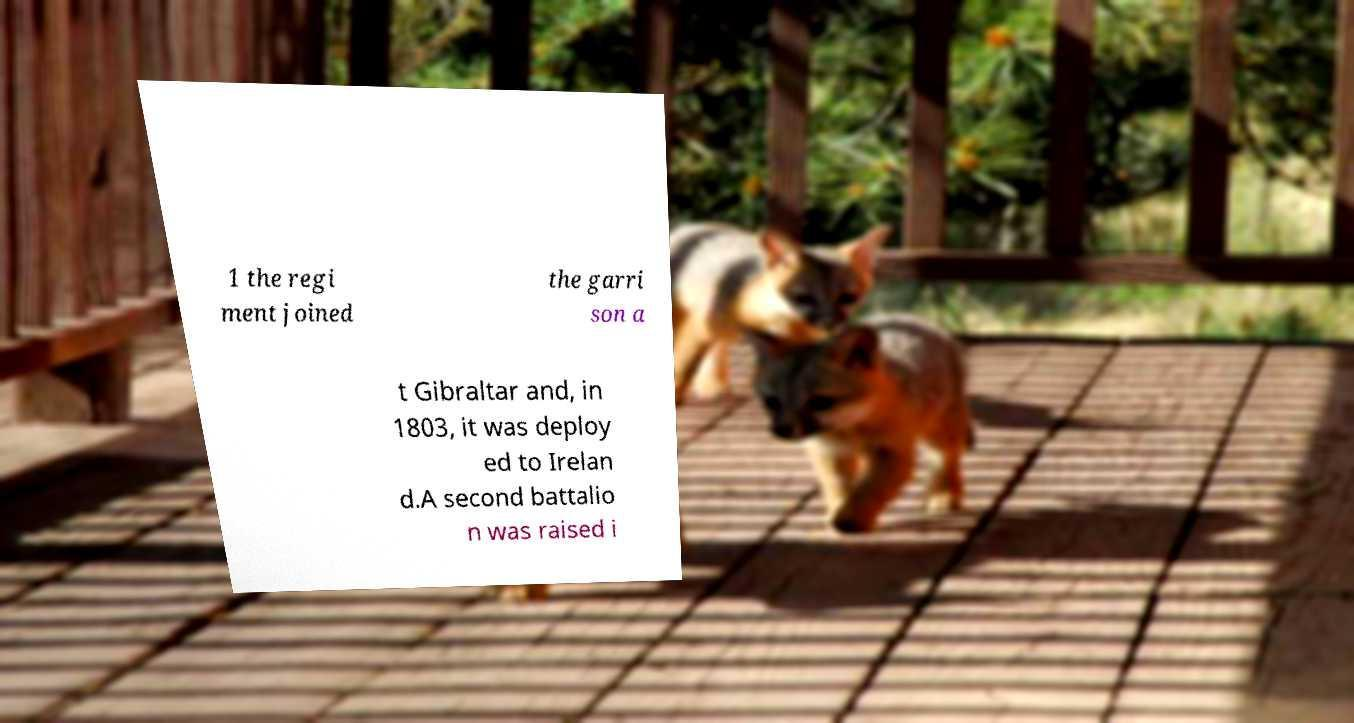For documentation purposes, I need the text within this image transcribed. Could you provide that? 1 the regi ment joined the garri son a t Gibraltar and, in 1803, it was deploy ed to Irelan d.A second battalio n was raised i 